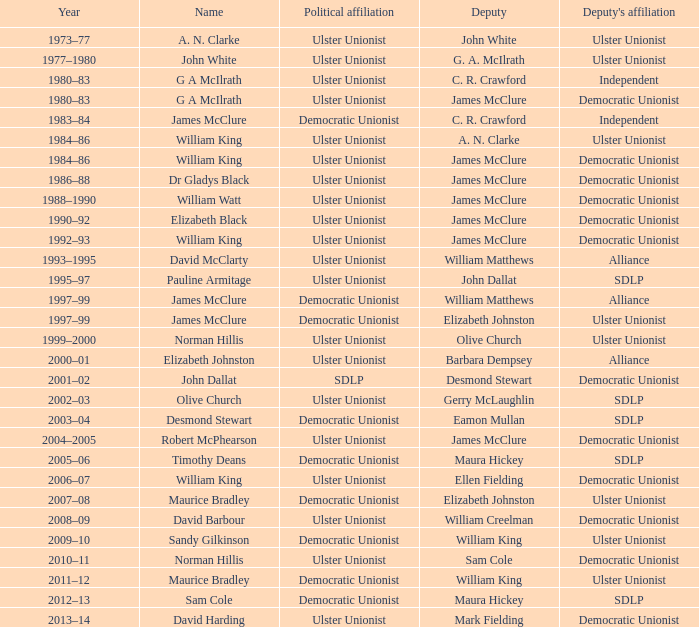To which political party is deputy john dallat affiliated? Ulster Unionist. 